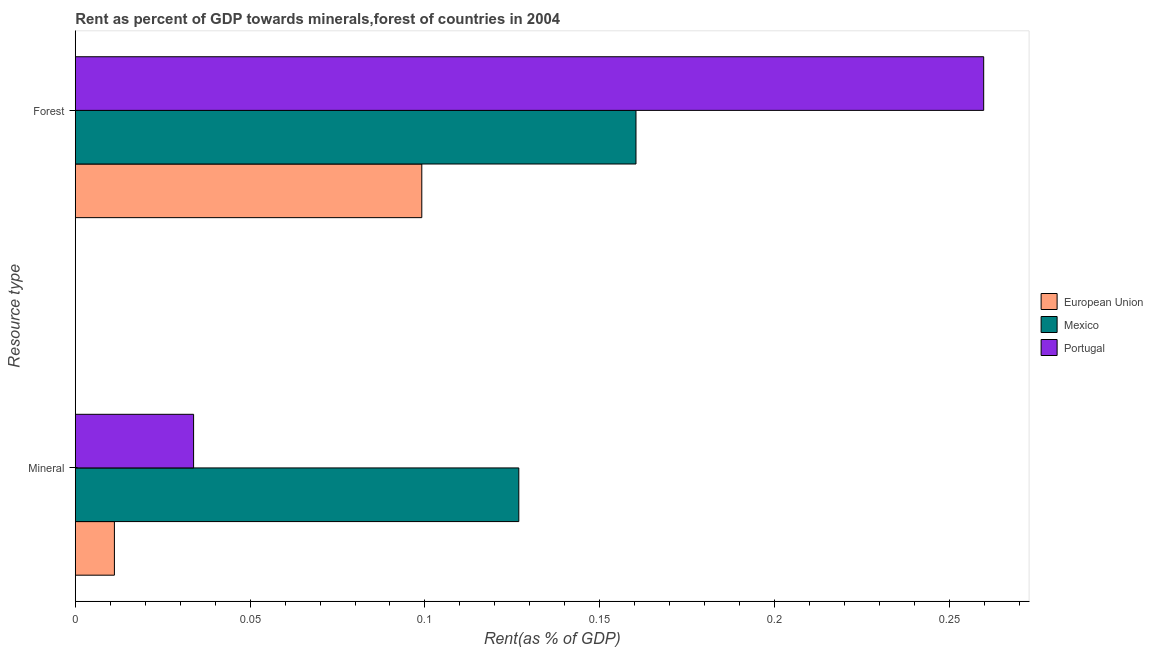How many different coloured bars are there?
Provide a short and direct response. 3. How many groups of bars are there?
Your answer should be compact. 2. Are the number of bars per tick equal to the number of legend labels?
Your answer should be very brief. Yes. How many bars are there on the 1st tick from the bottom?
Keep it short and to the point. 3. What is the label of the 1st group of bars from the top?
Offer a very short reply. Forest. What is the forest rent in Mexico?
Your answer should be very brief. 0.16. Across all countries, what is the maximum forest rent?
Offer a very short reply. 0.26. Across all countries, what is the minimum mineral rent?
Give a very brief answer. 0.01. In which country was the mineral rent maximum?
Provide a short and direct response. Mexico. What is the total mineral rent in the graph?
Your answer should be very brief. 0.17. What is the difference between the mineral rent in Mexico and that in Portugal?
Your response must be concise. 0.09. What is the difference between the forest rent in European Union and the mineral rent in Portugal?
Your response must be concise. 0.07. What is the average mineral rent per country?
Provide a succinct answer. 0.06. What is the difference between the mineral rent and forest rent in European Union?
Your answer should be very brief. -0.09. What is the ratio of the forest rent in Mexico to that in Portugal?
Offer a terse response. 0.62. In how many countries, is the mineral rent greater than the average mineral rent taken over all countries?
Provide a succinct answer. 1. What does the 3rd bar from the bottom in Mineral represents?
Give a very brief answer. Portugal. How many bars are there?
Make the answer very short. 6. Does the graph contain any zero values?
Provide a succinct answer. No. Does the graph contain grids?
Offer a terse response. No. Where does the legend appear in the graph?
Offer a very short reply. Center right. How are the legend labels stacked?
Give a very brief answer. Vertical. What is the title of the graph?
Provide a short and direct response. Rent as percent of GDP towards minerals,forest of countries in 2004. Does "Sri Lanka" appear as one of the legend labels in the graph?
Your answer should be compact. No. What is the label or title of the X-axis?
Give a very brief answer. Rent(as % of GDP). What is the label or title of the Y-axis?
Ensure brevity in your answer.  Resource type. What is the Rent(as % of GDP) in European Union in Mineral?
Provide a succinct answer. 0.01. What is the Rent(as % of GDP) in Mexico in Mineral?
Provide a short and direct response. 0.13. What is the Rent(as % of GDP) in Portugal in Mineral?
Offer a terse response. 0.03. What is the Rent(as % of GDP) of European Union in Forest?
Your answer should be very brief. 0.1. What is the Rent(as % of GDP) in Mexico in Forest?
Your response must be concise. 0.16. What is the Rent(as % of GDP) of Portugal in Forest?
Keep it short and to the point. 0.26. Across all Resource type, what is the maximum Rent(as % of GDP) in European Union?
Offer a very short reply. 0.1. Across all Resource type, what is the maximum Rent(as % of GDP) of Mexico?
Make the answer very short. 0.16. Across all Resource type, what is the maximum Rent(as % of GDP) of Portugal?
Offer a very short reply. 0.26. Across all Resource type, what is the minimum Rent(as % of GDP) in European Union?
Keep it short and to the point. 0.01. Across all Resource type, what is the minimum Rent(as % of GDP) of Mexico?
Make the answer very short. 0.13. Across all Resource type, what is the minimum Rent(as % of GDP) in Portugal?
Keep it short and to the point. 0.03. What is the total Rent(as % of GDP) in European Union in the graph?
Make the answer very short. 0.11. What is the total Rent(as % of GDP) of Mexico in the graph?
Your answer should be very brief. 0.29. What is the total Rent(as % of GDP) in Portugal in the graph?
Offer a very short reply. 0.29. What is the difference between the Rent(as % of GDP) of European Union in Mineral and that in Forest?
Offer a very short reply. -0.09. What is the difference between the Rent(as % of GDP) in Mexico in Mineral and that in Forest?
Offer a very short reply. -0.03. What is the difference between the Rent(as % of GDP) of Portugal in Mineral and that in Forest?
Ensure brevity in your answer.  -0.23. What is the difference between the Rent(as % of GDP) of European Union in Mineral and the Rent(as % of GDP) of Mexico in Forest?
Your response must be concise. -0.15. What is the difference between the Rent(as % of GDP) of European Union in Mineral and the Rent(as % of GDP) of Portugal in Forest?
Offer a terse response. -0.25. What is the difference between the Rent(as % of GDP) of Mexico in Mineral and the Rent(as % of GDP) of Portugal in Forest?
Ensure brevity in your answer.  -0.13. What is the average Rent(as % of GDP) of European Union per Resource type?
Keep it short and to the point. 0.06. What is the average Rent(as % of GDP) in Mexico per Resource type?
Offer a terse response. 0.14. What is the average Rent(as % of GDP) of Portugal per Resource type?
Your answer should be compact. 0.15. What is the difference between the Rent(as % of GDP) of European Union and Rent(as % of GDP) of Mexico in Mineral?
Offer a terse response. -0.12. What is the difference between the Rent(as % of GDP) in European Union and Rent(as % of GDP) in Portugal in Mineral?
Keep it short and to the point. -0.02. What is the difference between the Rent(as % of GDP) of Mexico and Rent(as % of GDP) of Portugal in Mineral?
Offer a terse response. 0.09. What is the difference between the Rent(as % of GDP) of European Union and Rent(as % of GDP) of Mexico in Forest?
Your answer should be very brief. -0.06. What is the difference between the Rent(as % of GDP) in European Union and Rent(as % of GDP) in Portugal in Forest?
Offer a very short reply. -0.16. What is the difference between the Rent(as % of GDP) of Mexico and Rent(as % of GDP) of Portugal in Forest?
Make the answer very short. -0.1. What is the ratio of the Rent(as % of GDP) in European Union in Mineral to that in Forest?
Provide a short and direct response. 0.11. What is the ratio of the Rent(as % of GDP) of Mexico in Mineral to that in Forest?
Keep it short and to the point. 0.79. What is the ratio of the Rent(as % of GDP) of Portugal in Mineral to that in Forest?
Offer a very short reply. 0.13. What is the difference between the highest and the second highest Rent(as % of GDP) of European Union?
Provide a succinct answer. 0.09. What is the difference between the highest and the second highest Rent(as % of GDP) in Mexico?
Offer a terse response. 0.03. What is the difference between the highest and the second highest Rent(as % of GDP) of Portugal?
Give a very brief answer. 0.23. What is the difference between the highest and the lowest Rent(as % of GDP) in European Union?
Provide a short and direct response. 0.09. What is the difference between the highest and the lowest Rent(as % of GDP) in Mexico?
Your answer should be very brief. 0.03. What is the difference between the highest and the lowest Rent(as % of GDP) in Portugal?
Provide a short and direct response. 0.23. 